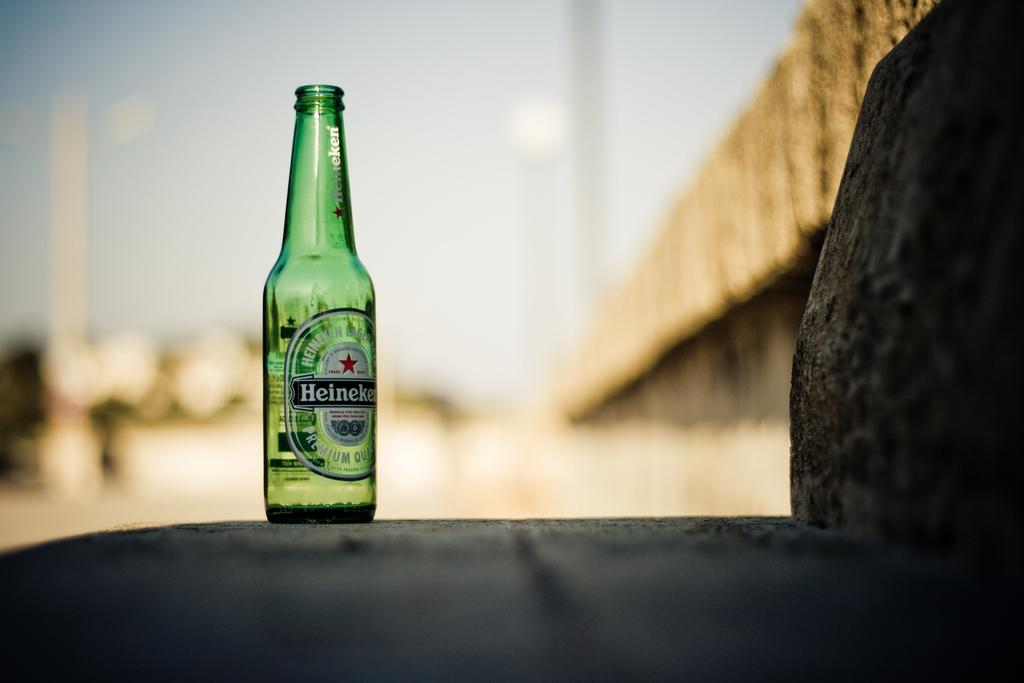<image>
Share a concise interpretation of the image provided. A green Heineken bottle sits outside on a stair. 